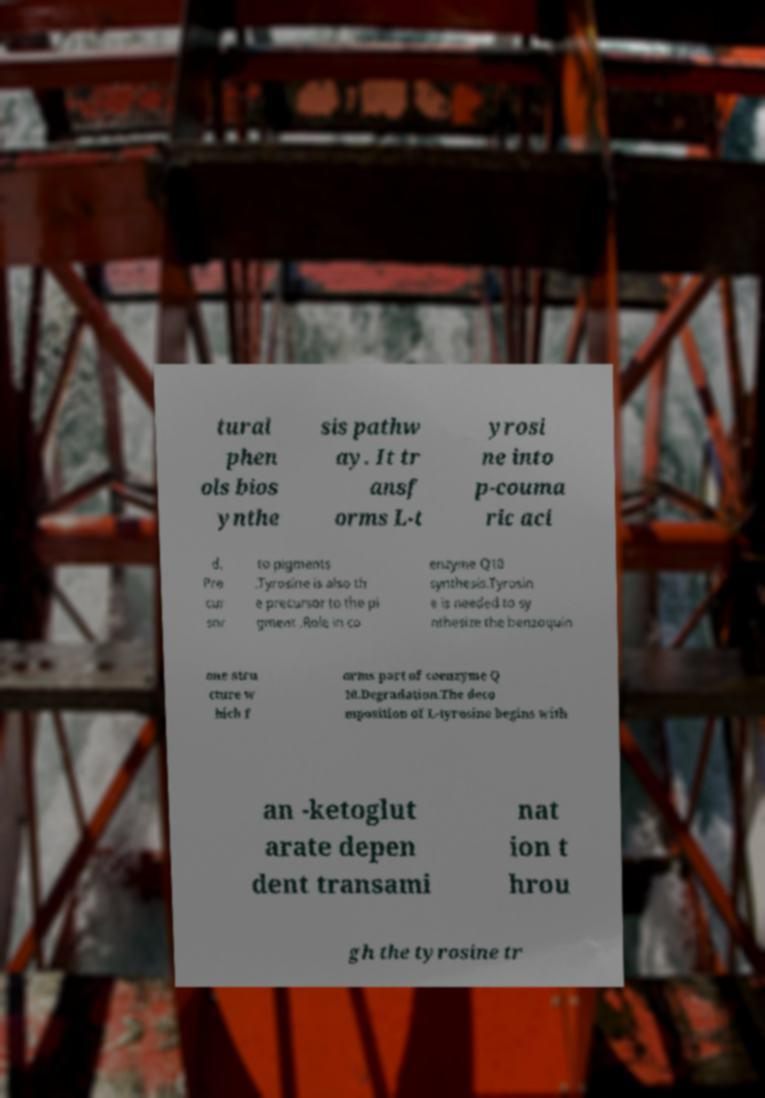Can you accurately transcribe the text from the provided image for me? tural phen ols bios ynthe sis pathw ay. It tr ansf orms L-t yrosi ne into p-couma ric aci d. Pre cur sor to pigments .Tyrosine is also th e precursor to the pi gment .Role in co enzyme Q10 synthesis.Tyrosin e is needed to sy nthesize the benzoquin one stru cture w hich f orms part of coenzyme Q 10.Degradation.The deco mposition of L-tyrosine begins with an -ketoglut arate depen dent transami nat ion t hrou gh the tyrosine tr 